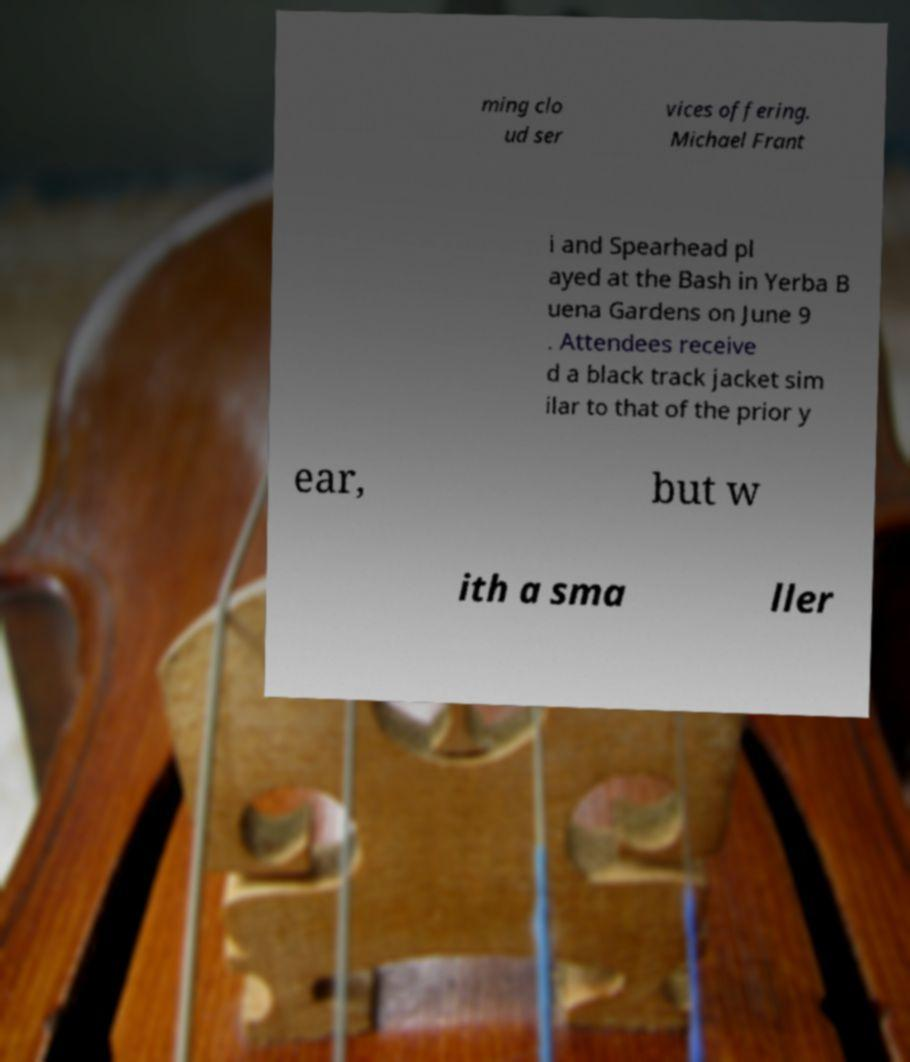For documentation purposes, I need the text within this image transcribed. Could you provide that? ming clo ud ser vices offering. Michael Frant i and Spearhead pl ayed at the Bash in Yerba B uena Gardens on June 9 . Attendees receive d a black track jacket sim ilar to that of the prior y ear, but w ith a sma ller 